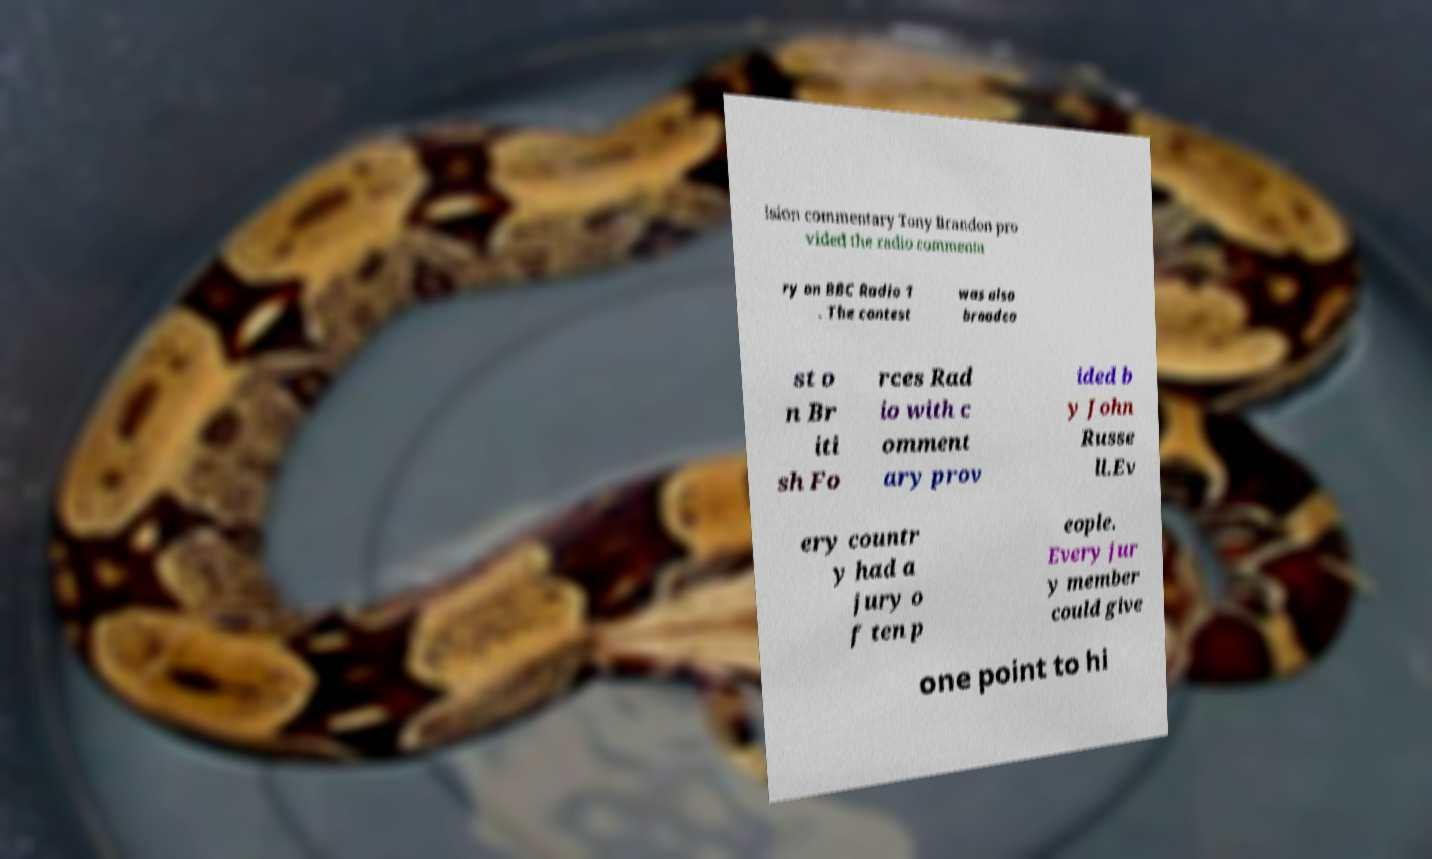Can you read and provide the text displayed in the image?This photo seems to have some interesting text. Can you extract and type it out for me? ision commentary Tony Brandon pro vided the radio commenta ry on BBC Radio 1 . The contest was also broadca st o n Br iti sh Fo rces Rad io with c omment ary prov ided b y John Russe ll.Ev ery countr y had a jury o f ten p eople. Every jur y member could give one point to hi 